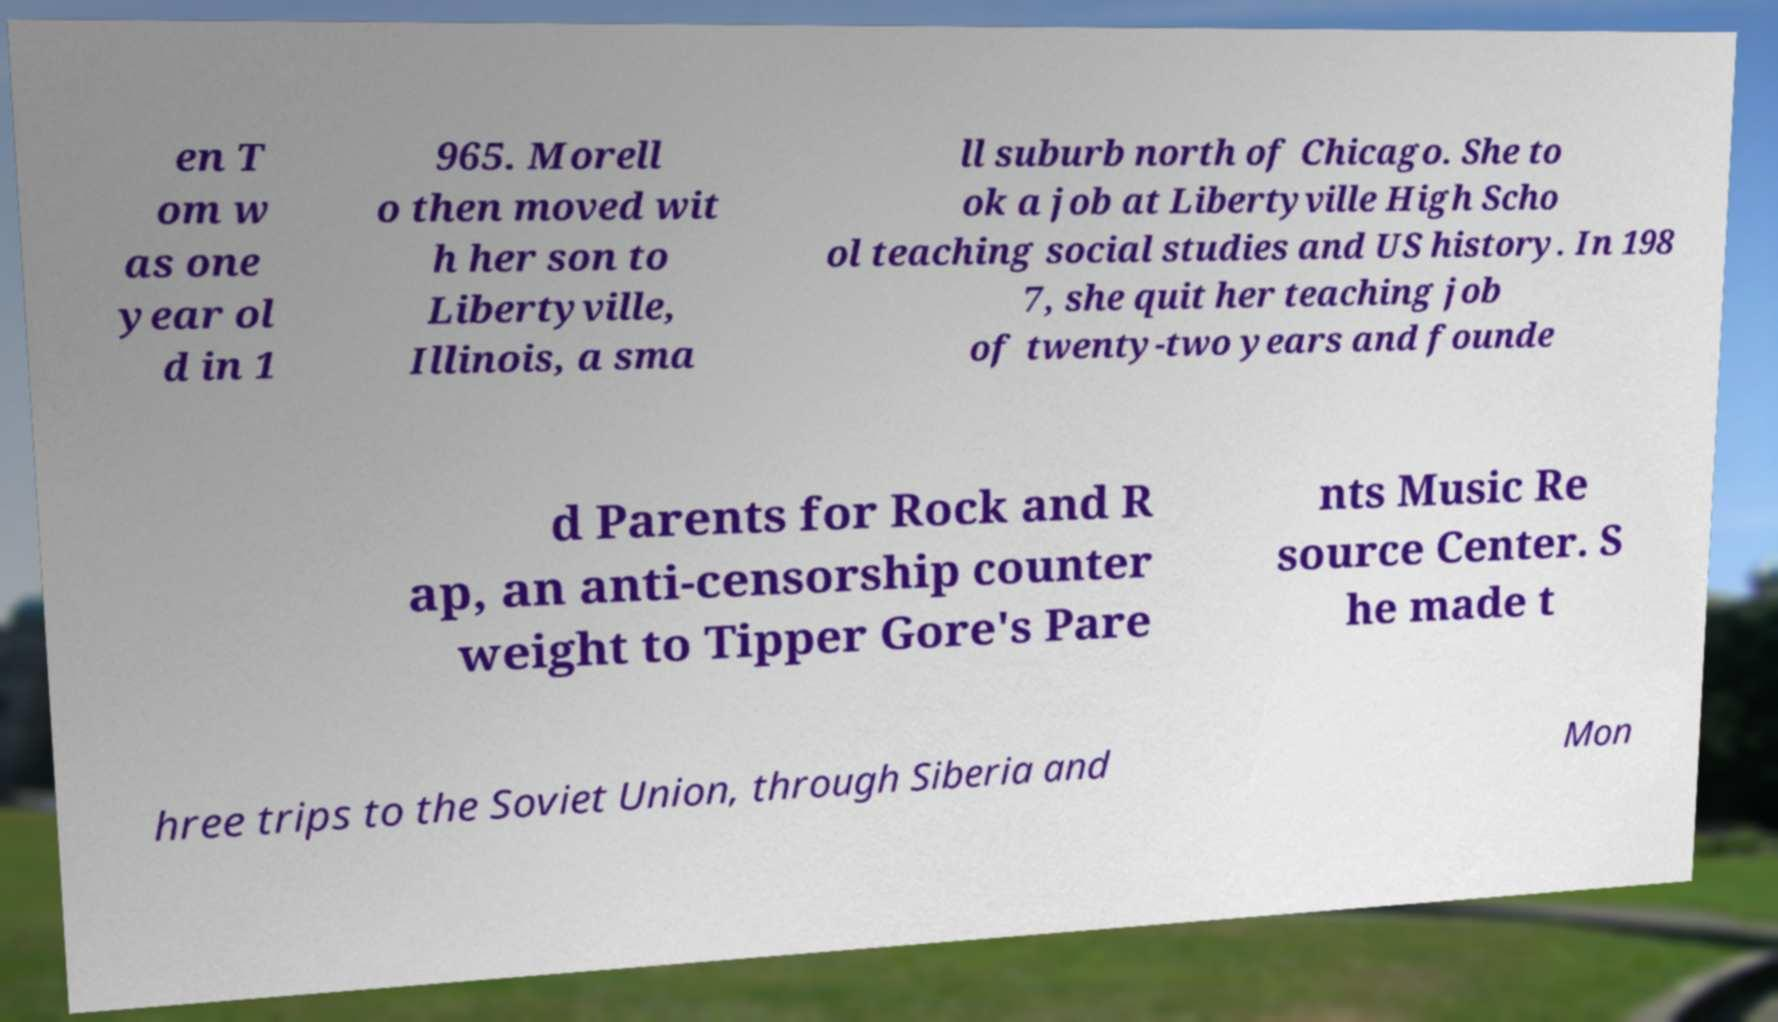There's text embedded in this image that I need extracted. Can you transcribe it verbatim? en T om w as one year ol d in 1 965. Morell o then moved wit h her son to Libertyville, Illinois, a sma ll suburb north of Chicago. She to ok a job at Libertyville High Scho ol teaching social studies and US history. In 198 7, she quit her teaching job of twenty-two years and founde d Parents for Rock and R ap, an anti-censorship counter weight to Tipper Gore's Pare nts Music Re source Center. S he made t hree trips to the Soviet Union, through Siberia and Mon 